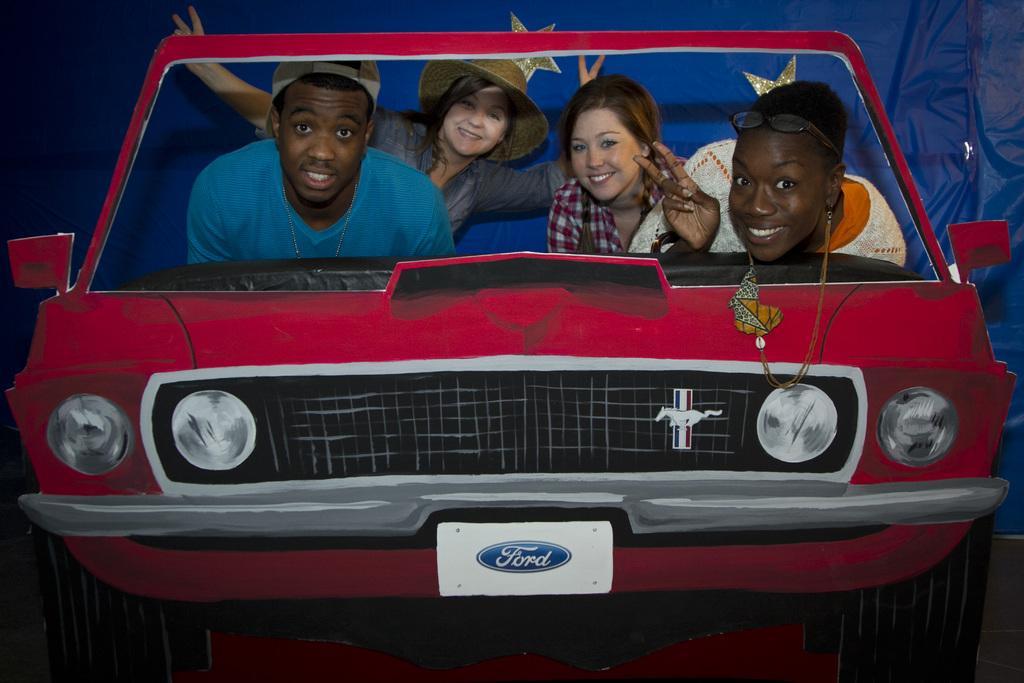Could you give a brief overview of what you see in this image? Four people are sitting in the car. On the right side lady is wearing goggles. On the left side person is wearing a cap. And this is a red color car. On the car there is a logo. In the background, there is a blue curtain. 